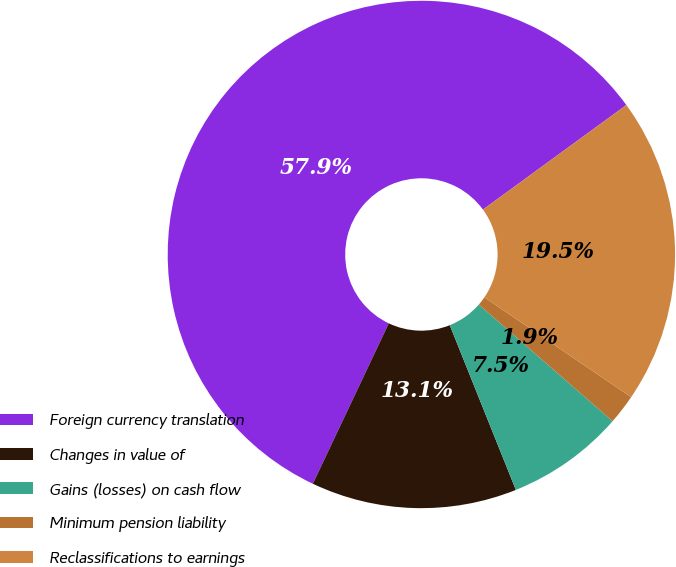Convert chart. <chart><loc_0><loc_0><loc_500><loc_500><pie_chart><fcel>Foreign currency translation<fcel>Changes in value of<fcel>Gains (losses) on cash flow<fcel>Minimum pension liability<fcel>Reclassifications to earnings<nl><fcel>57.93%<fcel>13.11%<fcel>7.51%<fcel>1.91%<fcel>19.53%<nl></chart> 